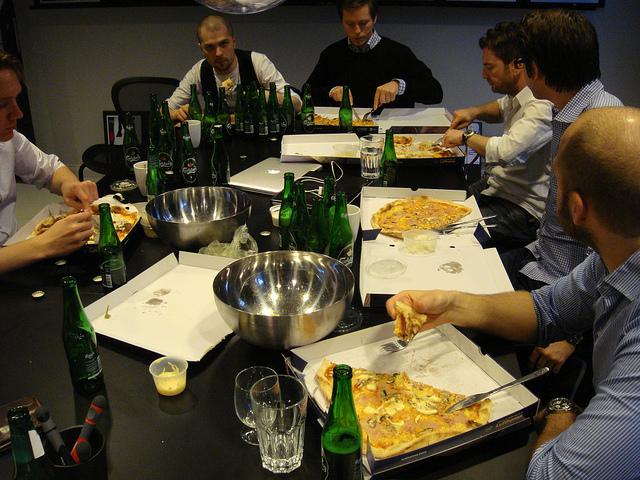What color is the pot?
Answer briefly. Silver. What type of pizza is the man holding up?
Be succinct. Cheese. What food are they eating?
Be succinct. Pizza. What type of gathering is taking place?
Write a very short answer. Meeting. Are the guys wearing blue shirts?
Keep it brief. Yes. Are any of the men drinking a beverage?
Be succinct. No. How many people are seated?
Give a very brief answer. 6. What is the man holding?
Keep it brief. Pizza. Does beer go well with this food?
Short answer required. Yes. Are they eating yet?
Be succinct. Yes. 